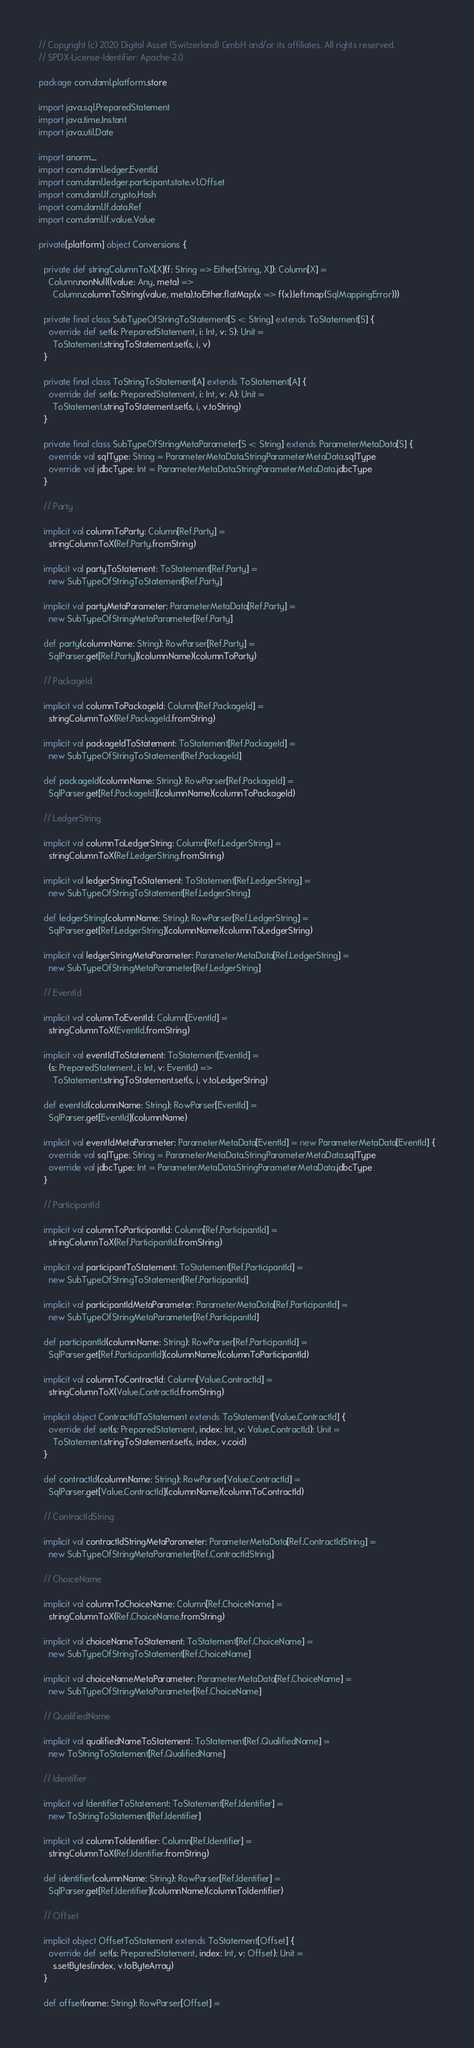Convert code to text. <code><loc_0><loc_0><loc_500><loc_500><_Scala_>// Copyright (c) 2020 Digital Asset (Switzerland) GmbH and/or its affiliates. All rights reserved.
// SPDX-License-Identifier: Apache-2.0

package com.daml.platform.store

import java.sql.PreparedStatement
import java.time.Instant
import java.util.Date

import anorm._
import com.daml.ledger.EventId
import com.daml.ledger.participant.state.v1.Offset
import com.daml.lf.crypto.Hash
import com.daml.lf.data.Ref
import com.daml.lf.value.Value

private[platform] object Conversions {

  private def stringColumnToX[X](f: String => Either[String, X]): Column[X] =
    Column.nonNull((value: Any, meta) =>
      Column.columnToString(value, meta).toEither.flatMap(x => f(x).left.map(SqlMappingError)))

  private final class SubTypeOfStringToStatement[S <: String] extends ToStatement[S] {
    override def set(s: PreparedStatement, i: Int, v: S): Unit =
      ToStatement.stringToStatement.set(s, i, v)
  }

  private final class ToStringToStatement[A] extends ToStatement[A] {
    override def set(s: PreparedStatement, i: Int, v: A): Unit =
      ToStatement.stringToStatement.set(s, i, v.toString)
  }

  private final class SubTypeOfStringMetaParameter[S <: String] extends ParameterMetaData[S] {
    override val sqlType: String = ParameterMetaData.StringParameterMetaData.sqlType
    override val jdbcType: Int = ParameterMetaData.StringParameterMetaData.jdbcType
  }

  // Party

  implicit val columnToParty: Column[Ref.Party] =
    stringColumnToX(Ref.Party.fromString)

  implicit val partyToStatement: ToStatement[Ref.Party] =
    new SubTypeOfStringToStatement[Ref.Party]

  implicit val partyMetaParameter: ParameterMetaData[Ref.Party] =
    new SubTypeOfStringMetaParameter[Ref.Party]

  def party(columnName: String): RowParser[Ref.Party] =
    SqlParser.get[Ref.Party](columnName)(columnToParty)

  // PackageId

  implicit val columnToPackageId: Column[Ref.PackageId] =
    stringColumnToX(Ref.PackageId.fromString)

  implicit val packageIdToStatement: ToStatement[Ref.PackageId] =
    new SubTypeOfStringToStatement[Ref.PackageId]

  def packageId(columnName: String): RowParser[Ref.PackageId] =
    SqlParser.get[Ref.PackageId](columnName)(columnToPackageId)

  // LedgerString

  implicit val columnToLedgerString: Column[Ref.LedgerString] =
    stringColumnToX(Ref.LedgerString.fromString)

  implicit val ledgerStringToStatement: ToStatement[Ref.LedgerString] =
    new SubTypeOfStringToStatement[Ref.LedgerString]

  def ledgerString(columnName: String): RowParser[Ref.LedgerString] =
    SqlParser.get[Ref.LedgerString](columnName)(columnToLedgerString)

  implicit val ledgerStringMetaParameter: ParameterMetaData[Ref.LedgerString] =
    new SubTypeOfStringMetaParameter[Ref.LedgerString]

  // EventId

  implicit val columnToEventId: Column[EventId] =
    stringColumnToX(EventId.fromString)

  implicit val eventIdToStatement: ToStatement[EventId] =
    (s: PreparedStatement, i: Int, v: EventId) =>
      ToStatement.stringToStatement.set(s, i, v.toLedgerString)

  def eventId(columnName: String): RowParser[EventId] =
    SqlParser.get[EventId](columnName)

  implicit val eventIdMetaParameter: ParameterMetaData[EventId] = new ParameterMetaData[EventId] {
    override val sqlType: String = ParameterMetaData.StringParameterMetaData.sqlType
    override val jdbcType: Int = ParameterMetaData.StringParameterMetaData.jdbcType
  }

  // ParticipantId

  implicit val columnToParticipantId: Column[Ref.ParticipantId] =
    stringColumnToX(Ref.ParticipantId.fromString)

  implicit val participantToStatement: ToStatement[Ref.ParticipantId] =
    new SubTypeOfStringToStatement[Ref.ParticipantId]

  implicit val participantIdMetaParameter: ParameterMetaData[Ref.ParticipantId] =
    new SubTypeOfStringMetaParameter[Ref.ParticipantId]

  def participantId(columnName: String): RowParser[Ref.ParticipantId] =
    SqlParser.get[Ref.ParticipantId](columnName)(columnToParticipantId)

  implicit val columnToContractId: Column[Value.ContractId] =
    stringColumnToX(Value.ContractId.fromString)

  implicit object ContractIdToStatement extends ToStatement[Value.ContractId] {
    override def set(s: PreparedStatement, index: Int, v: Value.ContractId): Unit =
      ToStatement.stringToStatement.set(s, index, v.coid)
  }

  def contractId(columnName: String): RowParser[Value.ContractId] =
    SqlParser.get[Value.ContractId](columnName)(columnToContractId)

  // ContractIdString

  implicit val contractIdStringMetaParameter: ParameterMetaData[Ref.ContractIdString] =
    new SubTypeOfStringMetaParameter[Ref.ContractIdString]

  // ChoiceName

  implicit val columnToChoiceName: Column[Ref.ChoiceName] =
    stringColumnToX(Ref.ChoiceName.fromString)

  implicit val choiceNameToStatement: ToStatement[Ref.ChoiceName] =
    new SubTypeOfStringToStatement[Ref.ChoiceName]

  implicit val choiceNameMetaParameter: ParameterMetaData[Ref.ChoiceName] =
    new SubTypeOfStringMetaParameter[Ref.ChoiceName]

  // QualifiedName

  implicit val qualifiedNameToStatement: ToStatement[Ref.QualifiedName] =
    new ToStringToStatement[Ref.QualifiedName]

  // Identifier

  implicit val IdentifierToStatement: ToStatement[Ref.Identifier] =
    new ToStringToStatement[Ref.Identifier]

  implicit val columnToIdentifier: Column[Ref.Identifier] =
    stringColumnToX(Ref.Identifier.fromString)

  def identifier(columnName: String): RowParser[Ref.Identifier] =
    SqlParser.get[Ref.Identifier](columnName)(columnToIdentifier)

  // Offset

  implicit object OffsetToStatement extends ToStatement[Offset] {
    override def set(s: PreparedStatement, index: Int, v: Offset): Unit =
      s.setBytes(index, v.toByteArray)
  }

  def offset(name: String): RowParser[Offset] =</code> 